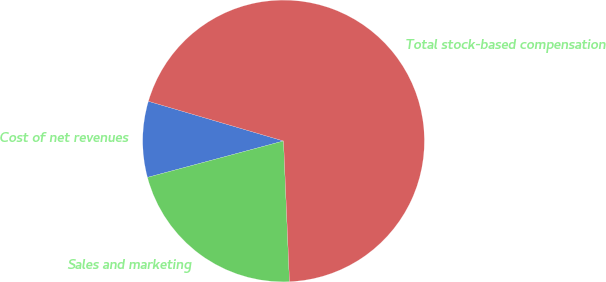Convert chart to OTSL. <chart><loc_0><loc_0><loc_500><loc_500><pie_chart><fcel>Cost of net revenues<fcel>Sales and marketing<fcel>Total stock-based compensation<nl><fcel>8.71%<fcel>21.51%<fcel>69.78%<nl></chart> 